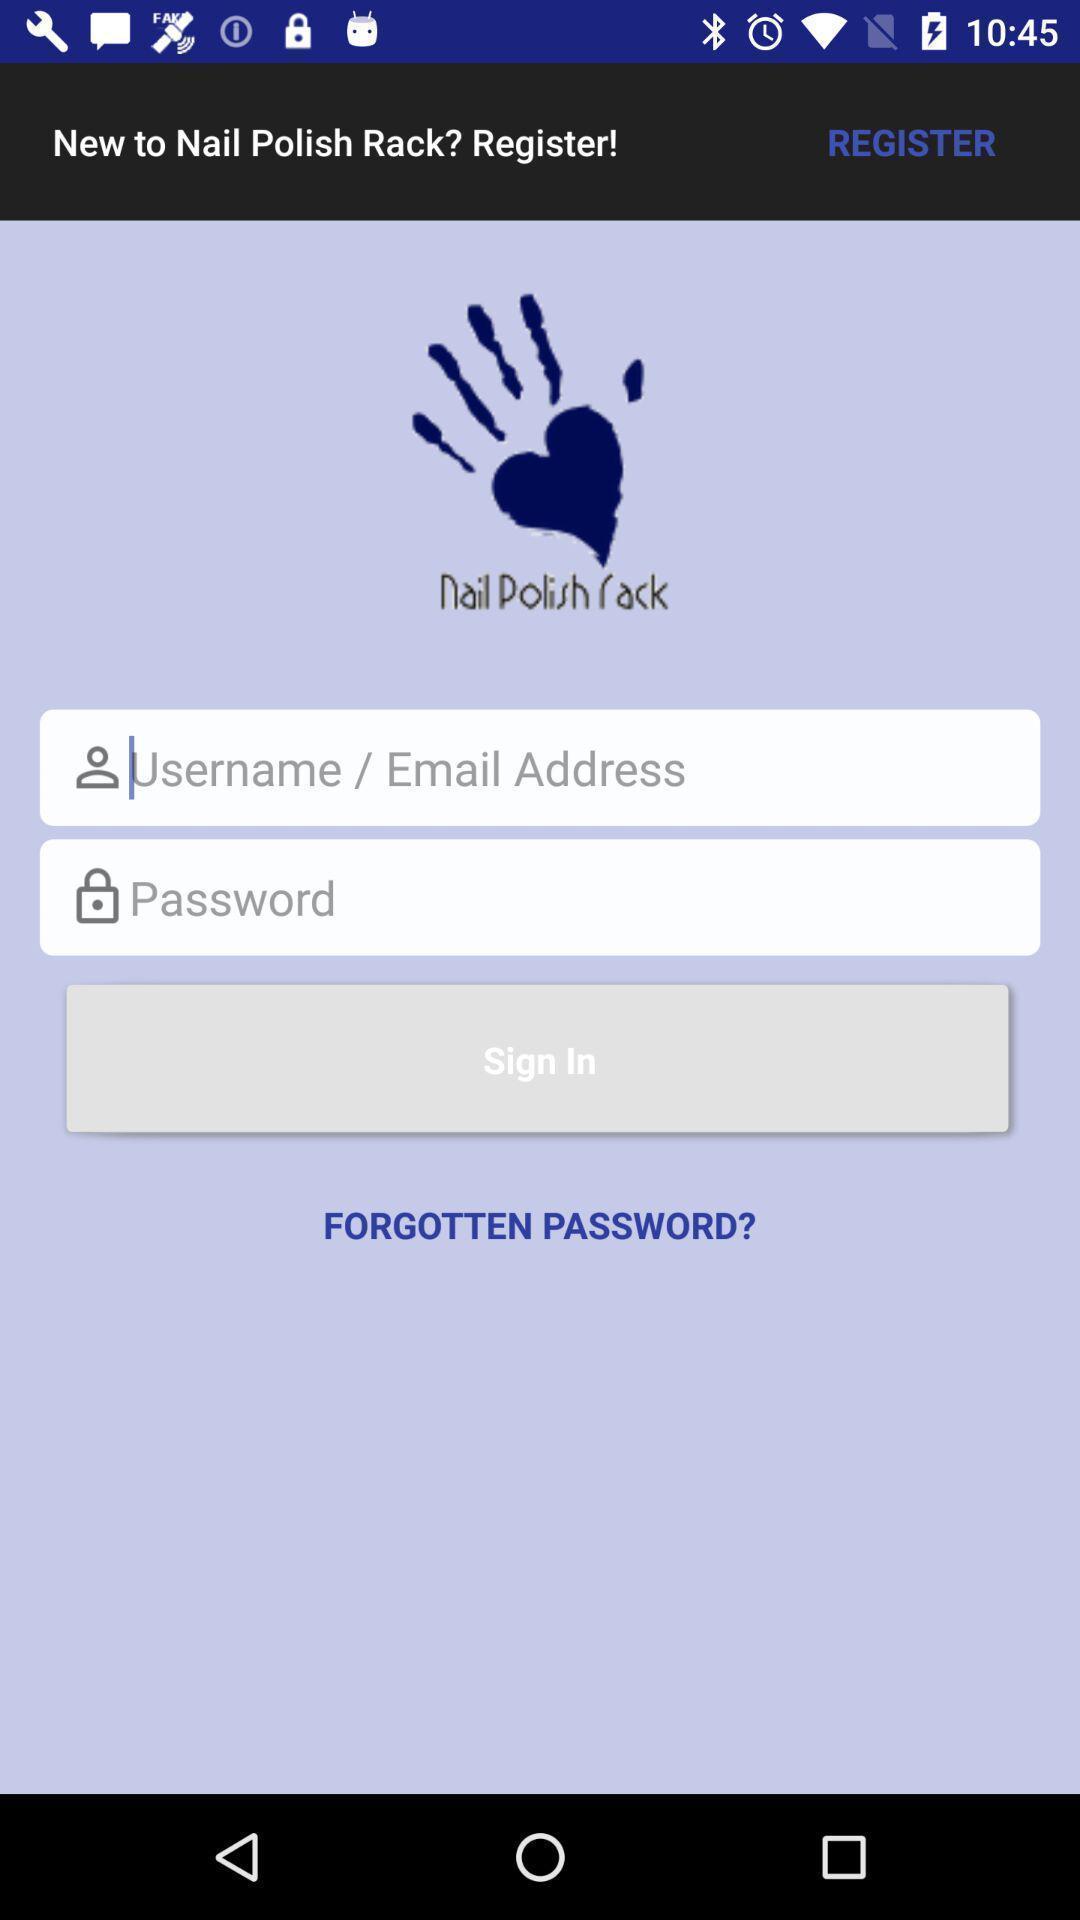Give me a summary of this screen capture. Welcome and log-in page for an application. 